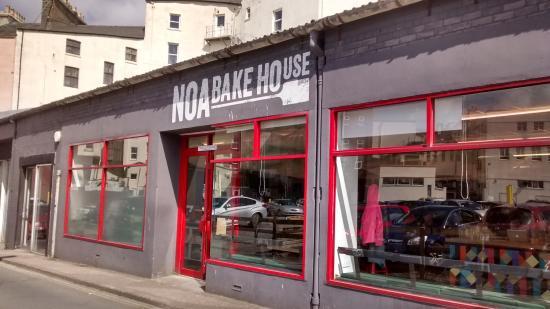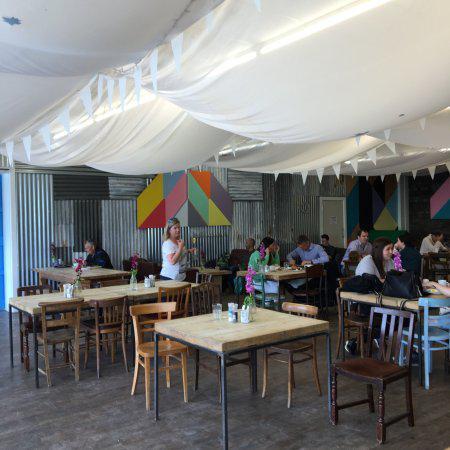The first image is the image on the left, the second image is the image on the right. For the images displayed, is the sentence "There is at least one chalkboard in the left image." factually correct? Answer yes or no. No. 